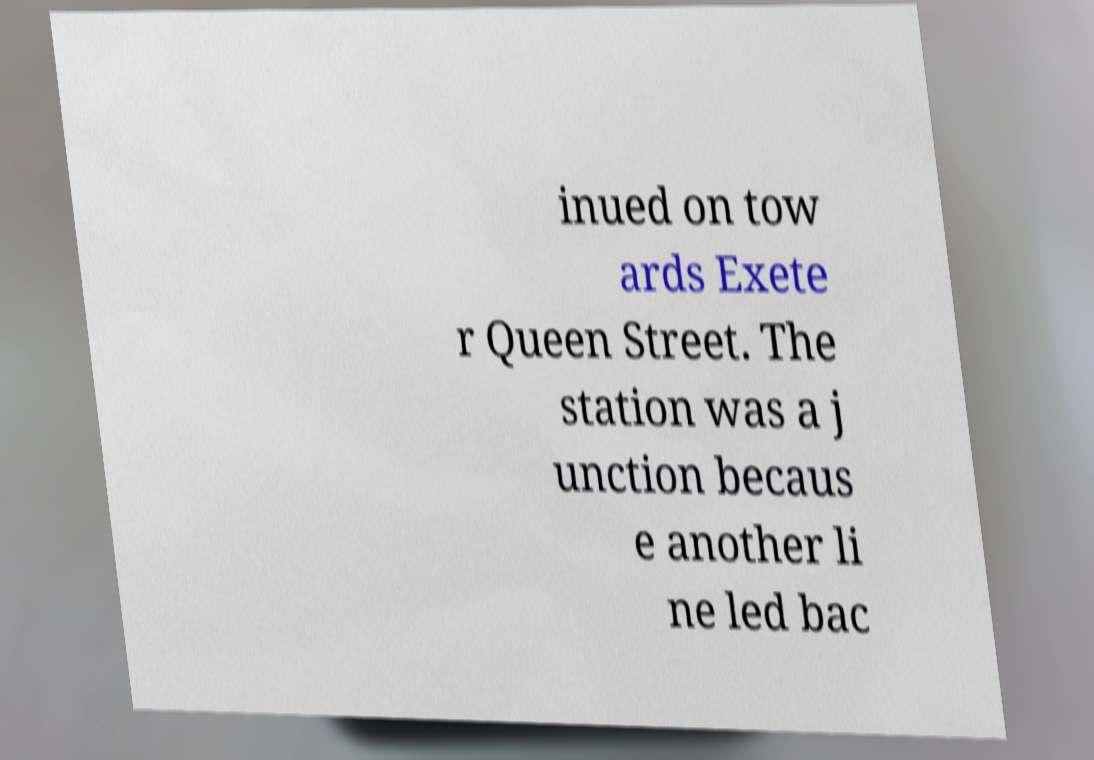Can you accurately transcribe the text from the provided image for me? inued on tow ards Exete r Queen Street. The station was a j unction becaus e another li ne led bac 